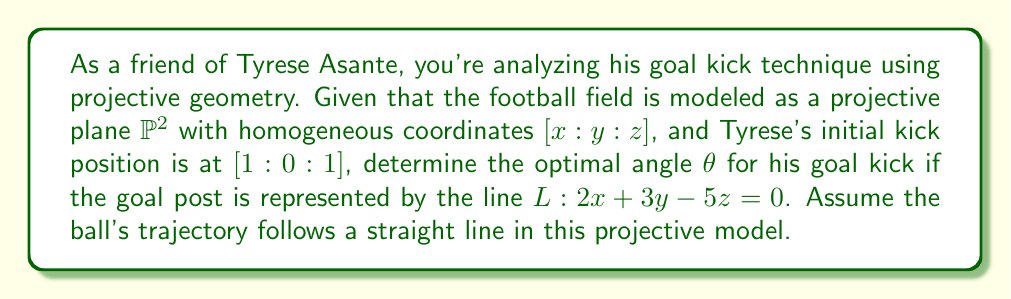Teach me how to tackle this problem. Let's approach this step-by-step using projective geometry:

1) In projective geometry, a line through two points $[x_1:y_1:z_1]$ and $[x_2:y_2:z_2]$ is given by the cross product of these points:

   $$l = [x_1:y_1:z_1] \times [x_2:y_2:z_2]$$

2) Tyrese's initial position is $[1:0:1]$. Let's call the point where the ball hits the goal line $[x:y:1]$. The line of the kick is:

   $$[1:0:1] \times [x:y:1] = [y : 1-x : -y]$$

3) For this line to intersect with the goal line $L$, we must have:

   $$2(y) + 3(1-x) - 5(-y) = 0$$

4) Simplifying:

   $$2y + 3 - 3x + 5y = 0$$
   $$7y - 3x + 3 = 0$$

5) This gives us a relationship between $x$ and $y$ for points on the goal line.

6) The angle $\theta$ of the kick is given by:

   $$\tan \theta = \frac{y}{x-1}$$

7) To find the optimal angle, we need to maximize this ratio. In projective geometry, the "best" point is often considered to be the point at infinity in the direction of the line.

8) The point at infinity on the goal line is found by setting $z=0$ in the equation of $L$:

   $$2x + 3y = 0$$
   $$y = -\frac{2}{3}x$$

9) Substituting this into our tan θ equation:

   $$\tan \theta = \frac{-\frac{2}{3}x}{x-1} = \frac{-2x}{3x-3}$$

10) As $x$ approaches infinity, this ratio approaches $-\frac{2}{3}$.

11) Therefore, the optimal angle $\theta$ is:

    $$\theta = \arctan(-\frac{2}{3})$$
Answer: $\arctan(-\frac{2}{3})$ radians or approximately $-33.69°$ 